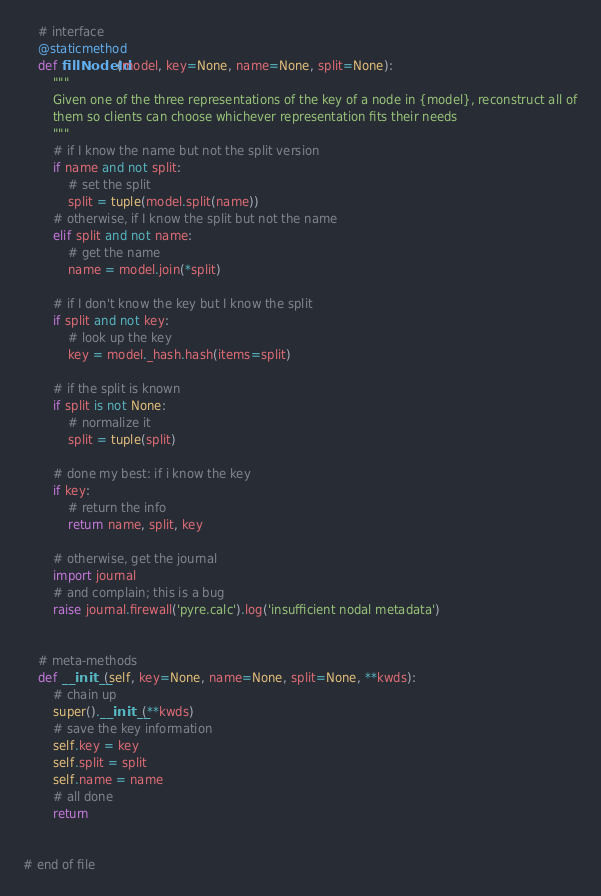<code> <loc_0><loc_0><loc_500><loc_500><_Python_>

    # interface
    @staticmethod
    def fillNodeId(model, key=None, name=None, split=None):
        """
        Given one of the three representations of the key of a node in {model}, reconstruct all of
        them so clients can choose whichever representation fits their needs
        """
        # if I know the name but not the split version
        if name and not split:
            # set the split
            split = tuple(model.split(name))
        # otherwise, if I know the split but not the name
        elif split and not name:
            # get the name
            name = model.join(*split)

        # if I don't know the key but I know the split
        if split and not key:
            # look up the key
            key = model._hash.hash(items=split)

        # if the split is known
        if split is not None:
            # normalize it
            split = tuple(split)

        # done my best: if i know the key
        if key:
            # return the info
            return name, split, key

        # otherwise, get the journal
        import journal
        # and complain; this is a bug
        raise journal.firewall('pyre.calc').log('insufficient nodal metadata')


    # meta-methods
    def __init__(self, key=None, name=None, split=None, **kwds):
        # chain up
        super().__init__(**kwds)
        # save the key information
        self.key = key
        self.split = split
        self.name = name
        # all done
        return


# end of file
</code> 